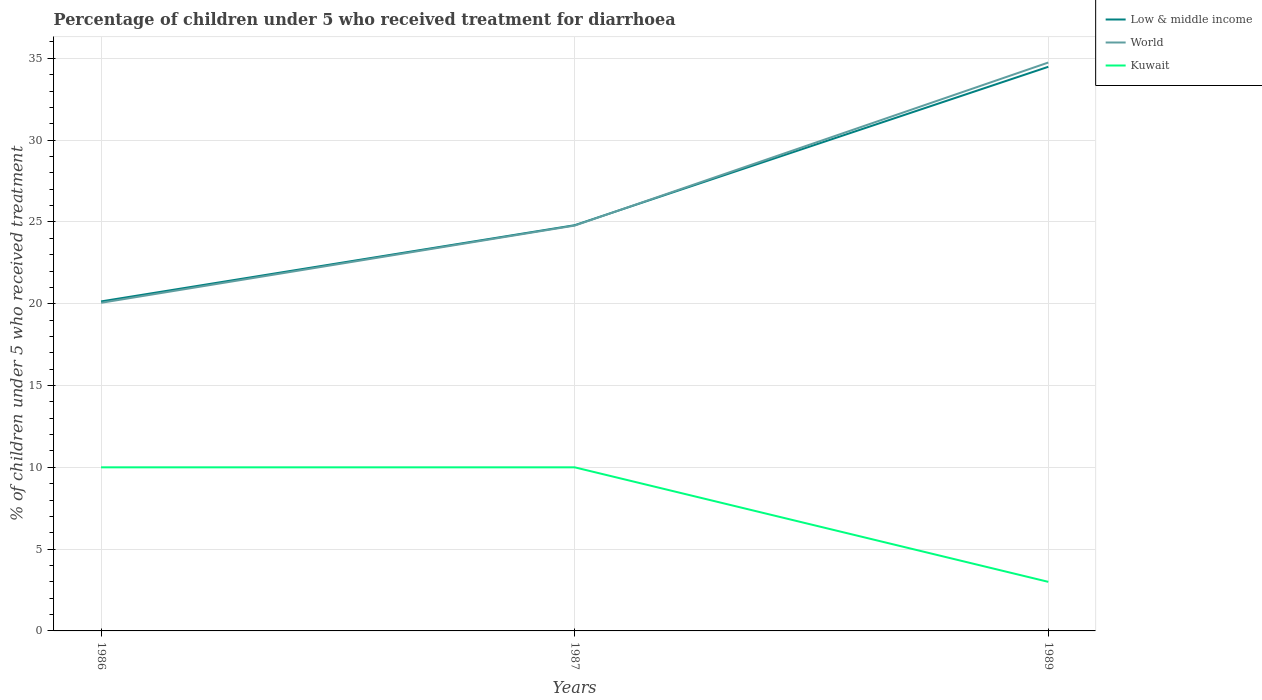Does the line corresponding to Low & middle income intersect with the line corresponding to Kuwait?
Give a very brief answer. No. Is the number of lines equal to the number of legend labels?
Your answer should be very brief. Yes. Across all years, what is the maximum percentage of children who received treatment for diarrhoea  in Low & middle income?
Ensure brevity in your answer.  20.14. In which year was the percentage of children who received treatment for diarrhoea  in Low & middle income maximum?
Your response must be concise. 1986. What is the total percentage of children who received treatment for diarrhoea  in World in the graph?
Provide a short and direct response. -9.97. What is the difference between the highest and the second highest percentage of children who received treatment for diarrhoea  in World?
Keep it short and to the point. 14.69. How many years are there in the graph?
Make the answer very short. 3. What is the difference between two consecutive major ticks on the Y-axis?
Provide a short and direct response. 5. Where does the legend appear in the graph?
Your answer should be very brief. Top right. How many legend labels are there?
Your response must be concise. 3. What is the title of the graph?
Your answer should be very brief. Percentage of children under 5 who received treatment for diarrhoea. Does "South Sudan" appear as one of the legend labels in the graph?
Make the answer very short. No. What is the label or title of the Y-axis?
Offer a terse response. % of children under 5 who received treatment. What is the % of children under 5 who received treatment in Low & middle income in 1986?
Give a very brief answer. 20.14. What is the % of children under 5 who received treatment of World in 1986?
Your response must be concise. 20.06. What is the % of children under 5 who received treatment in Kuwait in 1986?
Offer a terse response. 10. What is the % of children under 5 who received treatment in Low & middle income in 1987?
Your answer should be very brief. 24.8. What is the % of children under 5 who received treatment of World in 1987?
Your answer should be compact. 24.78. What is the % of children under 5 who received treatment of Low & middle income in 1989?
Your response must be concise. 34.48. What is the % of children under 5 who received treatment of World in 1989?
Give a very brief answer. 34.74. Across all years, what is the maximum % of children under 5 who received treatment of Low & middle income?
Make the answer very short. 34.48. Across all years, what is the maximum % of children under 5 who received treatment in World?
Your answer should be very brief. 34.74. Across all years, what is the minimum % of children under 5 who received treatment in Low & middle income?
Your response must be concise. 20.14. Across all years, what is the minimum % of children under 5 who received treatment of World?
Make the answer very short. 20.06. Across all years, what is the minimum % of children under 5 who received treatment in Kuwait?
Your answer should be very brief. 3. What is the total % of children under 5 who received treatment of Low & middle income in the graph?
Provide a short and direct response. 79.42. What is the total % of children under 5 who received treatment in World in the graph?
Ensure brevity in your answer.  79.58. What is the total % of children under 5 who received treatment in Kuwait in the graph?
Your response must be concise. 23. What is the difference between the % of children under 5 who received treatment of Low & middle income in 1986 and that in 1987?
Ensure brevity in your answer.  -4.66. What is the difference between the % of children under 5 who received treatment of World in 1986 and that in 1987?
Give a very brief answer. -4.72. What is the difference between the % of children under 5 who received treatment in Low & middle income in 1986 and that in 1989?
Offer a very short reply. -14.34. What is the difference between the % of children under 5 who received treatment in World in 1986 and that in 1989?
Give a very brief answer. -14.69. What is the difference between the % of children under 5 who received treatment of Kuwait in 1986 and that in 1989?
Your answer should be very brief. 7. What is the difference between the % of children under 5 who received treatment in Low & middle income in 1987 and that in 1989?
Ensure brevity in your answer.  -9.68. What is the difference between the % of children under 5 who received treatment in World in 1987 and that in 1989?
Your answer should be compact. -9.97. What is the difference between the % of children under 5 who received treatment in Kuwait in 1987 and that in 1989?
Offer a very short reply. 7. What is the difference between the % of children under 5 who received treatment of Low & middle income in 1986 and the % of children under 5 who received treatment of World in 1987?
Give a very brief answer. -4.64. What is the difference between the % of children under 5 who received treatment of Low & middle income in 1986 and the % of children under 5 who received treatment of Kuwait in 1987?
Your response must be concise. 10.14. What is the difference between the % of children under 5 who received treatment in World in 1986 and the % of children under 5 who received treatment in Kuwait in 1987?
Your answer should be very brief. 10.06. What is the difference between the % of children under 5 who received treatment in Low & middle income in 1986 and the % of children under 5 who received treatment in World in 1989?
Your answer should be very brief. -14.6. What is the difference between the % of children under 5 who received treatment of Low & middle income in 1986 and the % of children under 5 who received treatment of Kuwait in 1989?
Give a very brief answer. 17.14. What is the difference between the % of children under 5 who received treatment of World in 1986 and the % of children under 5 who received treatment of Kuwait in 1989?
Make the answer very short. 17.06. What is the difference between the % of children under 5 who received treatment of Low & middle income in 1987 and the % of children under 5 who received treatment of World in 1989?
Keep it short and to the point. -9.94. What is the difference between the % of children under 5 who received treatment of Low & middle income in 1987 and the % of children under 5 who received treatment of Kuwait in 1989?
Your answer should be very brief. 21.8. What is the difference between the % of children under 5 who received treatment in World in 1987 and the % of children under 5 who received treatment in Kuwait in 1989?
Make the answer very short. 21.78. What is the average % of children under 5 who received treatment in Low & middle income per year?
Offer a very short reply. 26.47. What is the average % of children under 5 who received treatment in World per year?
Offer a very short reply. 26.53. What is the average % of children under 5 who received treatment of Kuwait per year?
Your answer should be compact. 7.67. In the year 1986, what is the difference between the % of children under 5 who received treatment in Low & middle income and % of children under 5 who received treatment in World?
Provide a short and direct response. 0.08. In the year 1986, what is the difference between the % of children under 5 who received treatment of Low & middle income and % of children under 5 who received treatment of Kuwait?
Ensure brevity in your answer.  10.14. In the year 1986, what is the difference between the % of children under 5 who received treatment in World and % of children under 5 who received treatment in Kuwait?
Make the answer very short. 10.06. In the year 1987, what is the difference between the % of children under 5 who received treatment of Low & middle income and % of children under 5 who received treatment of World?
Give a very brief answer. 0.02. In the year 1987, what is the difference between the % of children under 5 who received treatment in Low & middle income and % of children under 5 who received treatment in Kuwait?
Ensure brevity in your answer.  14.8. In the year 1987, what is the difference between the % of children under 5 who received treatment of World and % of children under 5 who received treatment of Kuwait?
Ensure brevity in your answer.  14.78. In the year 1989, what is the difference between the % of children under 5 who received treatment of Low & middle income and % of children under 5 who received treatment of World?
Offer a terse response. -0.26. In the year 1989, what is the difference between the % of children under 5 who received treatment in Low & middle income and % of children under 5 who received treatment in Kuwait?
Your answer should be compact. 31.48. In the year 1989, what is the difference between the % of children under 5 who received treatment of World and % of children under 5 who received treatment of Kuwait?
Offer a very short reply. 31.74. What is the ratio of the % of children under 5 who received treatment in Low & middle income in 1986 to that in 1987?
Ensure brevity in your answer.  0.81. What is the ratio of the % of children under 5 who received treatment of World in 1986 to that in 1987?
Offer a terse response. 0.81. What is the ratio of the % of children under 5 who received treatment in Low & middle income in 1986 to that in 1989?
Keep it short and to the point. 0.58. What is the ratio of the % of children under 5 who received treatment of World in 1986 to that in 1989?
Your answer should be compact. 0.58. What is the ratio of the % of children under 5 who received treatment of Low & middle income in 1987 to that in 1989?
Keep it short and to the point. 0.72. What is the ratio of the % of children under 5 who received treatment in World in 1987 to that in 1989?
Provide a short and direct response. 0.71. What is the difference between the highest and the second highest % of children under 5 who received treatment of Low & middle income?
Your answer should be very brief. 9.68. What is the difference between the highest and the second highest % of children under 5 who received treatment in World?
Your response must be concise. 9.97. What is the difference between the highest and the second highest % of children under 5 who received treatment in Kuwait?
Provide a short and direct response. 0. What is the difference between the highest and the lowest % of children under 5 who received treatment of Low & middle income?
Your answer should be compact. 14.34. What is the difference between the highest and the lowest % of children under 5 who received treatment in World?
Your response must be concise. 14.69. What is the difference between the highest and the lowest % of children under 5 who received treatment in Kuwait?
Provide a succinct answer. 7. 